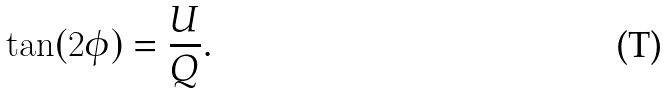<formula> <loc_0><loc_0><loc_500><loc_500>\tan ( 2 \phi ) = \frac { U } { Q } .</formula> 